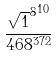Convert formula to latex. <formula><loc_0><loc_0><loc_500><loc_500>\frac { { \sqrt { 1 } ^ { 8 } } ^ { 1 0 } } { 4 6 8 ^ { 3 7 2 } }</formula> 